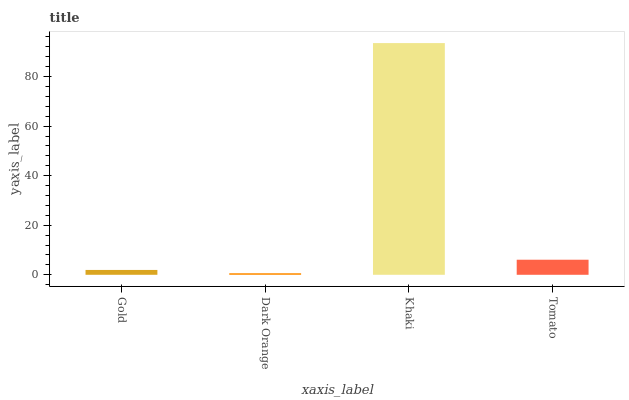Is Dark Orange the minimum?
Answer yes or no. Yes. Is Khaki the maximum?
Answer yes or no. Yes. Is Khaki the minimum?
Answer yes or no. No. Is Dark Orange the maximum?
Answer yes or no. No. Is Khaki greater than Dark Orange?
Answer yes or no. Yes. Is Dark Orange less than Khaki?
Answer yes or no. Yes. Is Dark Orange greater than Khaki?
Answer yes or no. No. Is Khaki less than Dark Orange?
Answer yes or no. No. Is Tomato the high median?
Answer yes or no. Yes. Is Gold the low median?
Answer yes or no. Yes. Is Khaki the high median?
Answer yes or no. No. Is Khaki the low median?
Answer yes or no. No. 